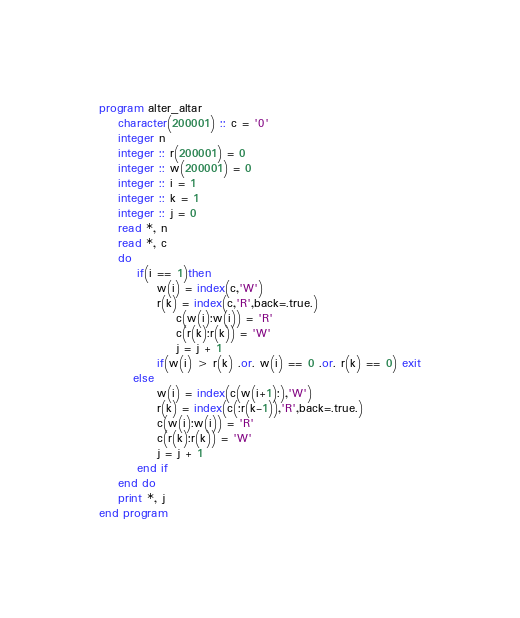<code> <loc_0><loc_0><loc_500><loc_500><_FORTRAN_>program alter_altar
    character(200001) :: c = '0'
    integer n
    integer :: r(200001) = 0
    integer :: w(200001) = 0
    integer :: i = 1
    integer :: k = 1
    integer :: j = 0
    read *, n
    read *, c
    do
        if(i == 1)then
            w(i) = index(c,'W')
            r(k) = index(c,'R',back=.true.)
                c(w(i):w(i)) = 'R'
                c(r(k):r(k)) = 'W'
                j = j + 1
            if(w(i) > r(k) .or. w(i) == 0 .or. r(k) == 0) exit
       else
            w(i) = index(c(w(i+1):),'W')
            r(k) = index(c(:r(k-1)),'R',back=.true.)
            c(w(i):w(i)) = 'R'
            c(r(k):r(k)) = 'W'
            j = j + 1
        end if
    end do
    print *, j
end program</code> 